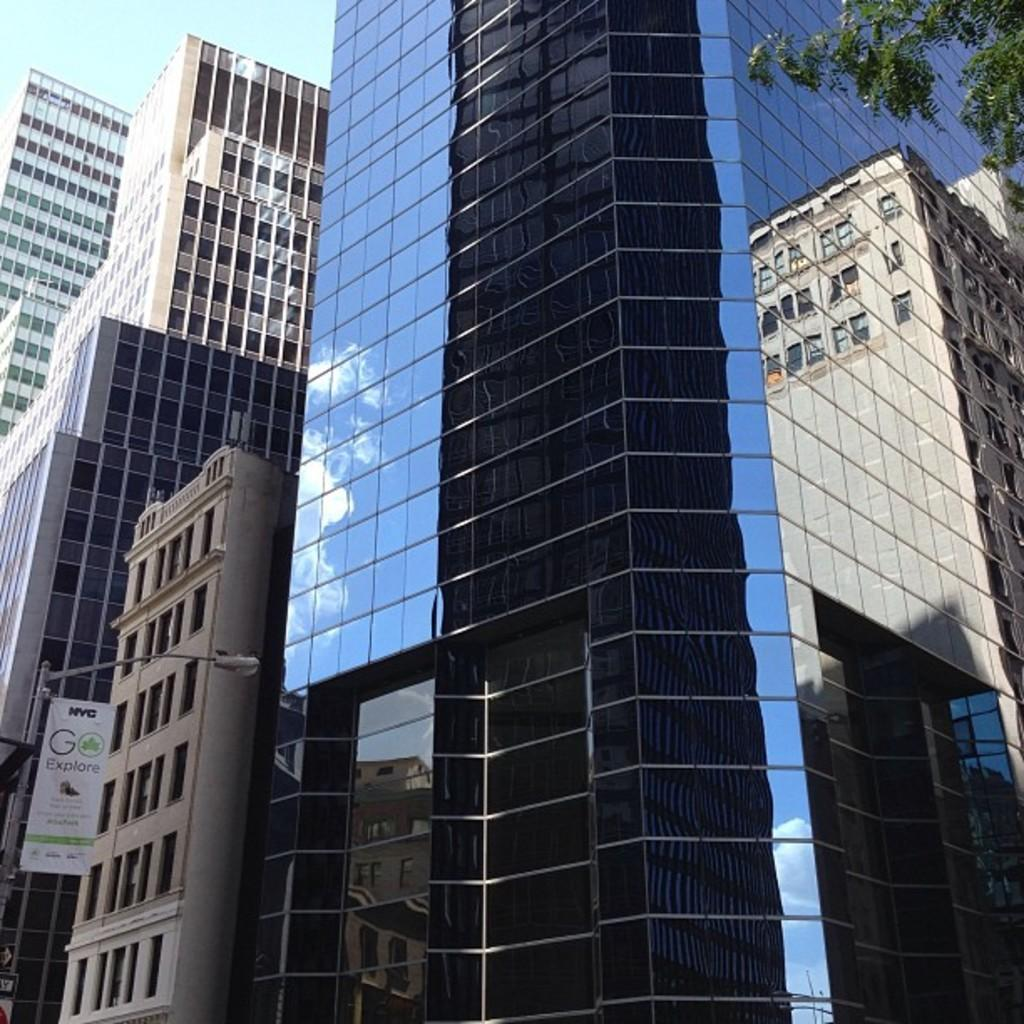What type of structures can be seen in the image? There are buildings in the image. What type of lighting is present in the image? There is a street light in the image. What additional feature can be seen in the image? There is a banner in the image. What type of natural element is present in the image? There is a tree in the image. What type of porter is carrying the banner in the image? There is no porter carrying a banner in the image; it is a static banner. How does the banner sort the different elements in the image? The banner does not sort any elements in the image; it is simply a decorative feature. 